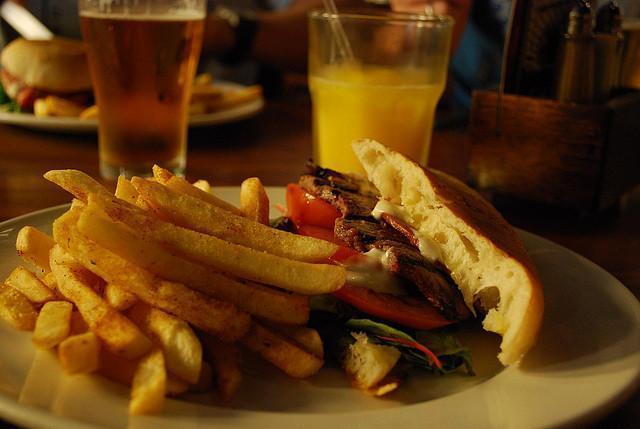How many cups are in the photo?
Give a very brief answer. 2. How many sandwiches are there?
Give a very brief answer. 2. 